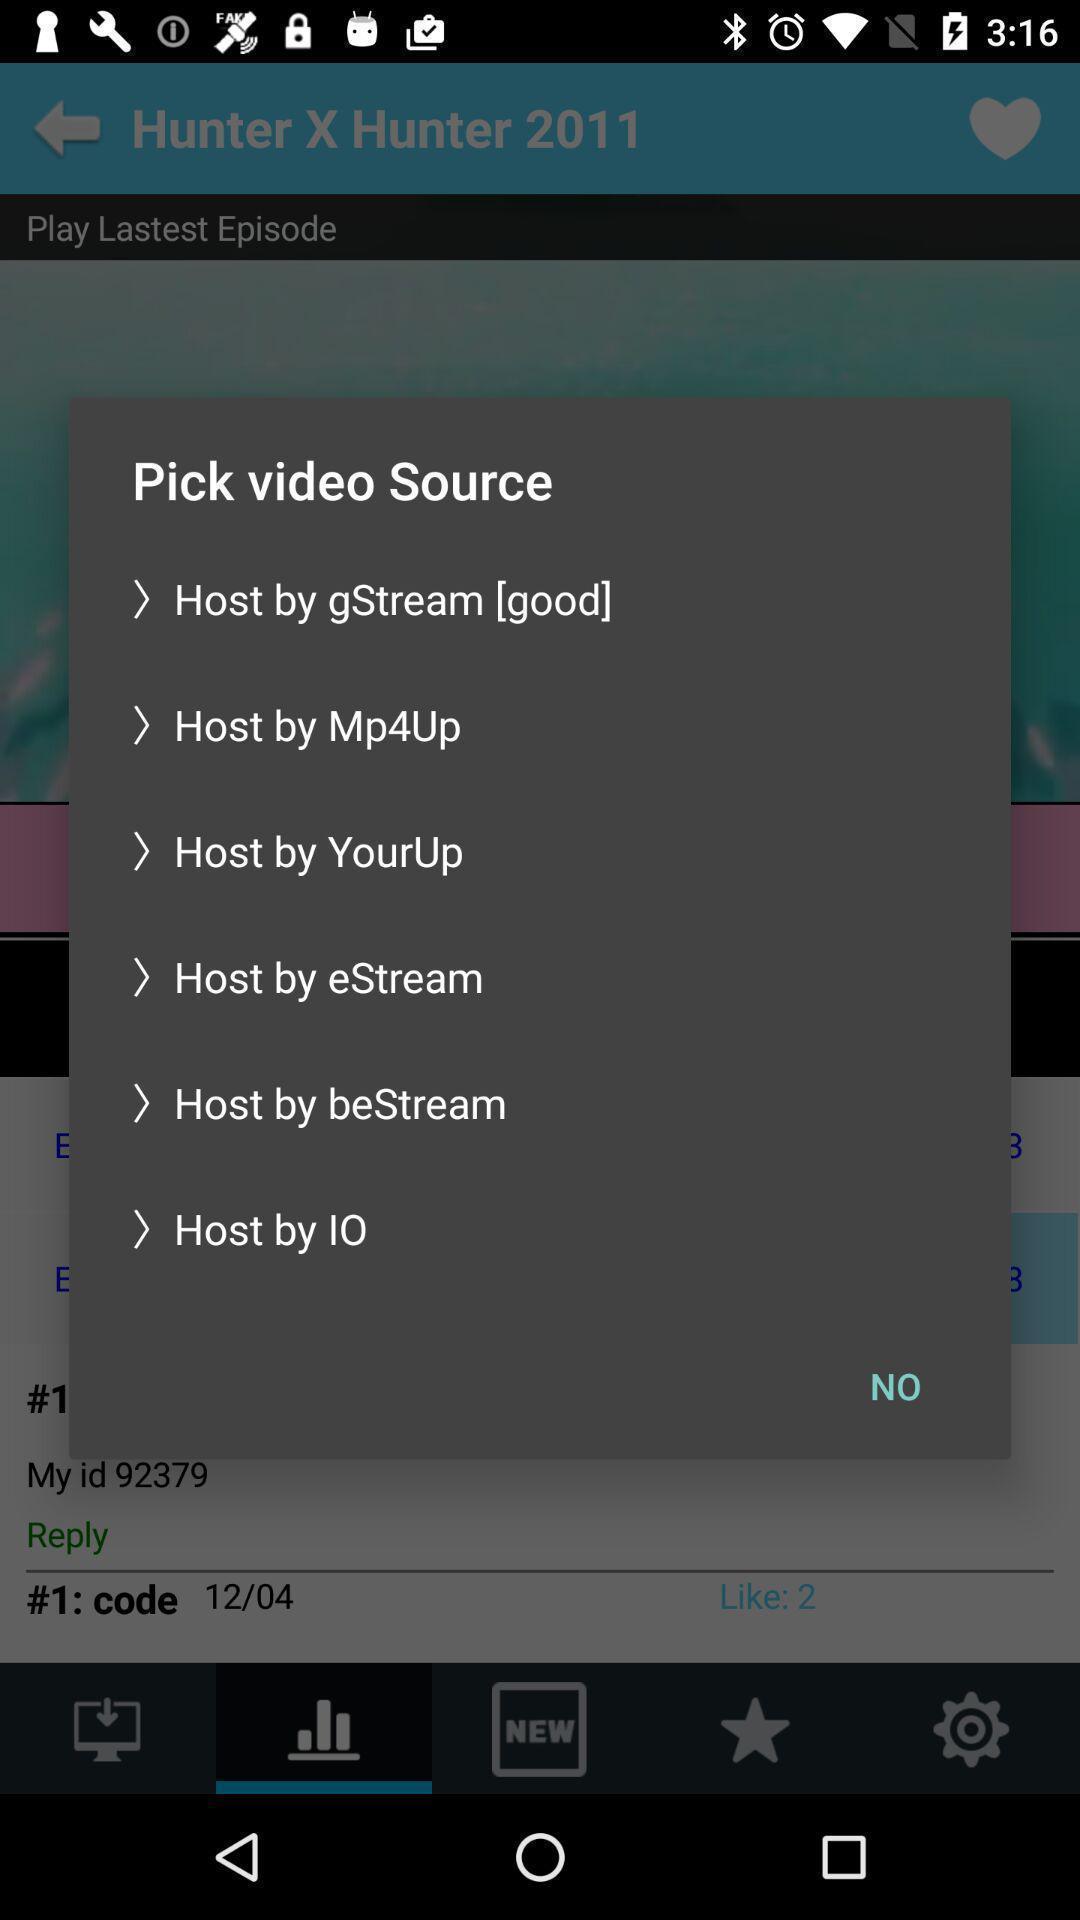Please provide a description for this image. Popup to choose a source from list in the app. 